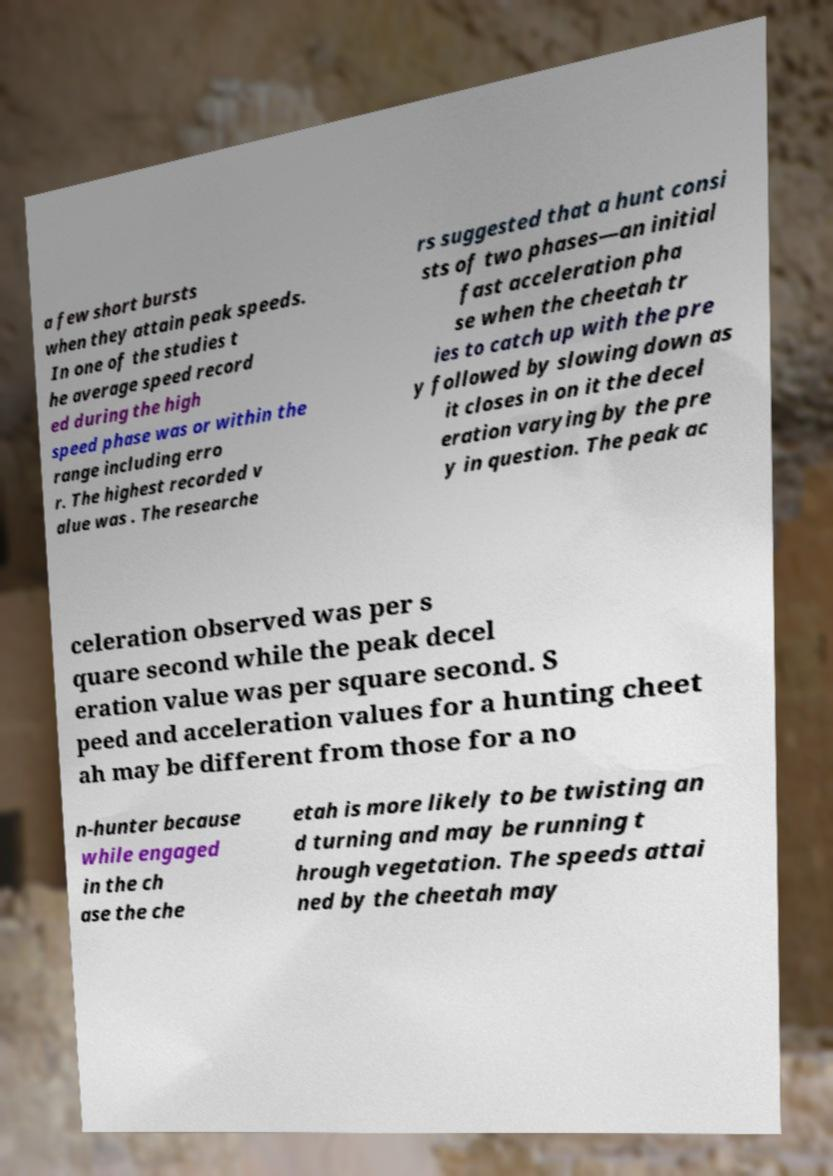For documentation purposes, I need the text within this image transcribed. Could you provide that? a few short bursts when they attain peak speeds. In one of the studies t he average speed record ed during the high speed phase was or within the range including erro r. The highest recorded v alue was . The researche rs suggested that a hunt consi sts of two phases—an initial fast acceleration pha se when the cheetah tr ies to catch up with the pre y followed by slowing down as it closes in on it the decel eration varying by the pre y in question. The peak ac celeration observed was per s quare second while the peak decel eration value was per square second. S peed and acceleration values for a hunting cheet ah may be different from those for a no n-hunter because while engaged in the ch ase the che etah is more likely to be twisting an d turning and may be running t hrough vegetation. The speeds attai ned by the cheetah may 